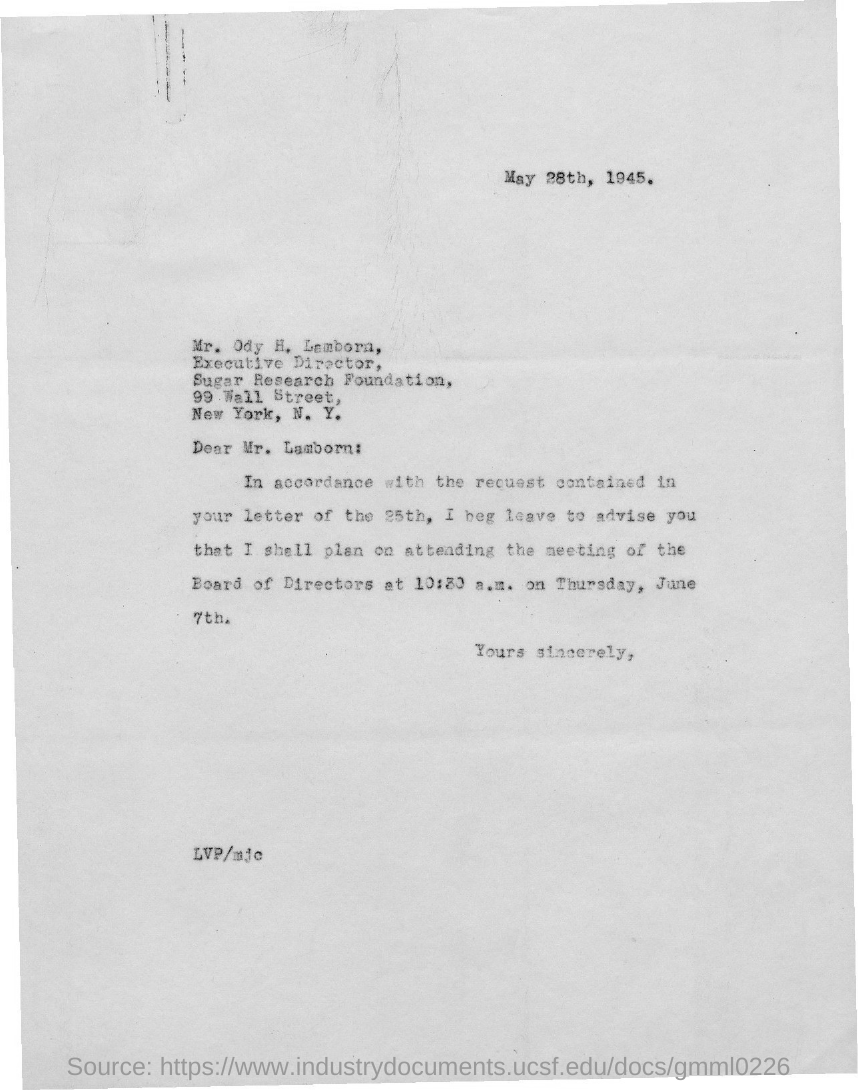Point out several critical features in this image. The document indicates that the date is May 28th, 1945. The letter is addressed to Mr. Ody H. Lamborn. 